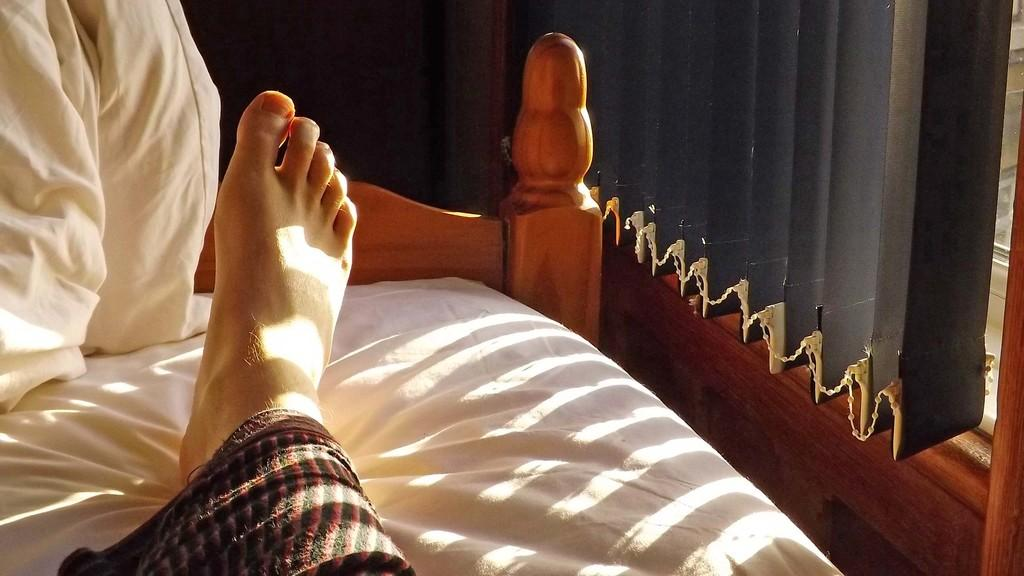What is the person doing in the image? There is a person sitting on the bed on the left side of the image. Can you describe any body parts of the person visible in the image? A person's leg is visible on the bed. What is visible on the right side of the image? There is a window on the right side of the image. What is associated with the window in the image? There is a curtain associated with the window. What type of structure is present in the image? There is a wall in the image. How many kittens are playing with rings under the crown in the image? There are no kittens, rings, or crowns present in the image. 